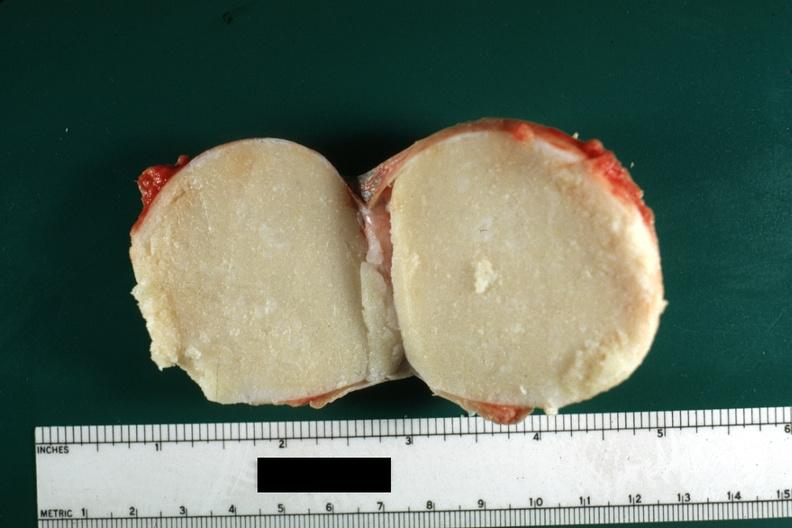what was typical cheese like yellow content and thin fibrous capsule this lesion from?
Answer the question using a single word or phrase. From the scrotal skin 